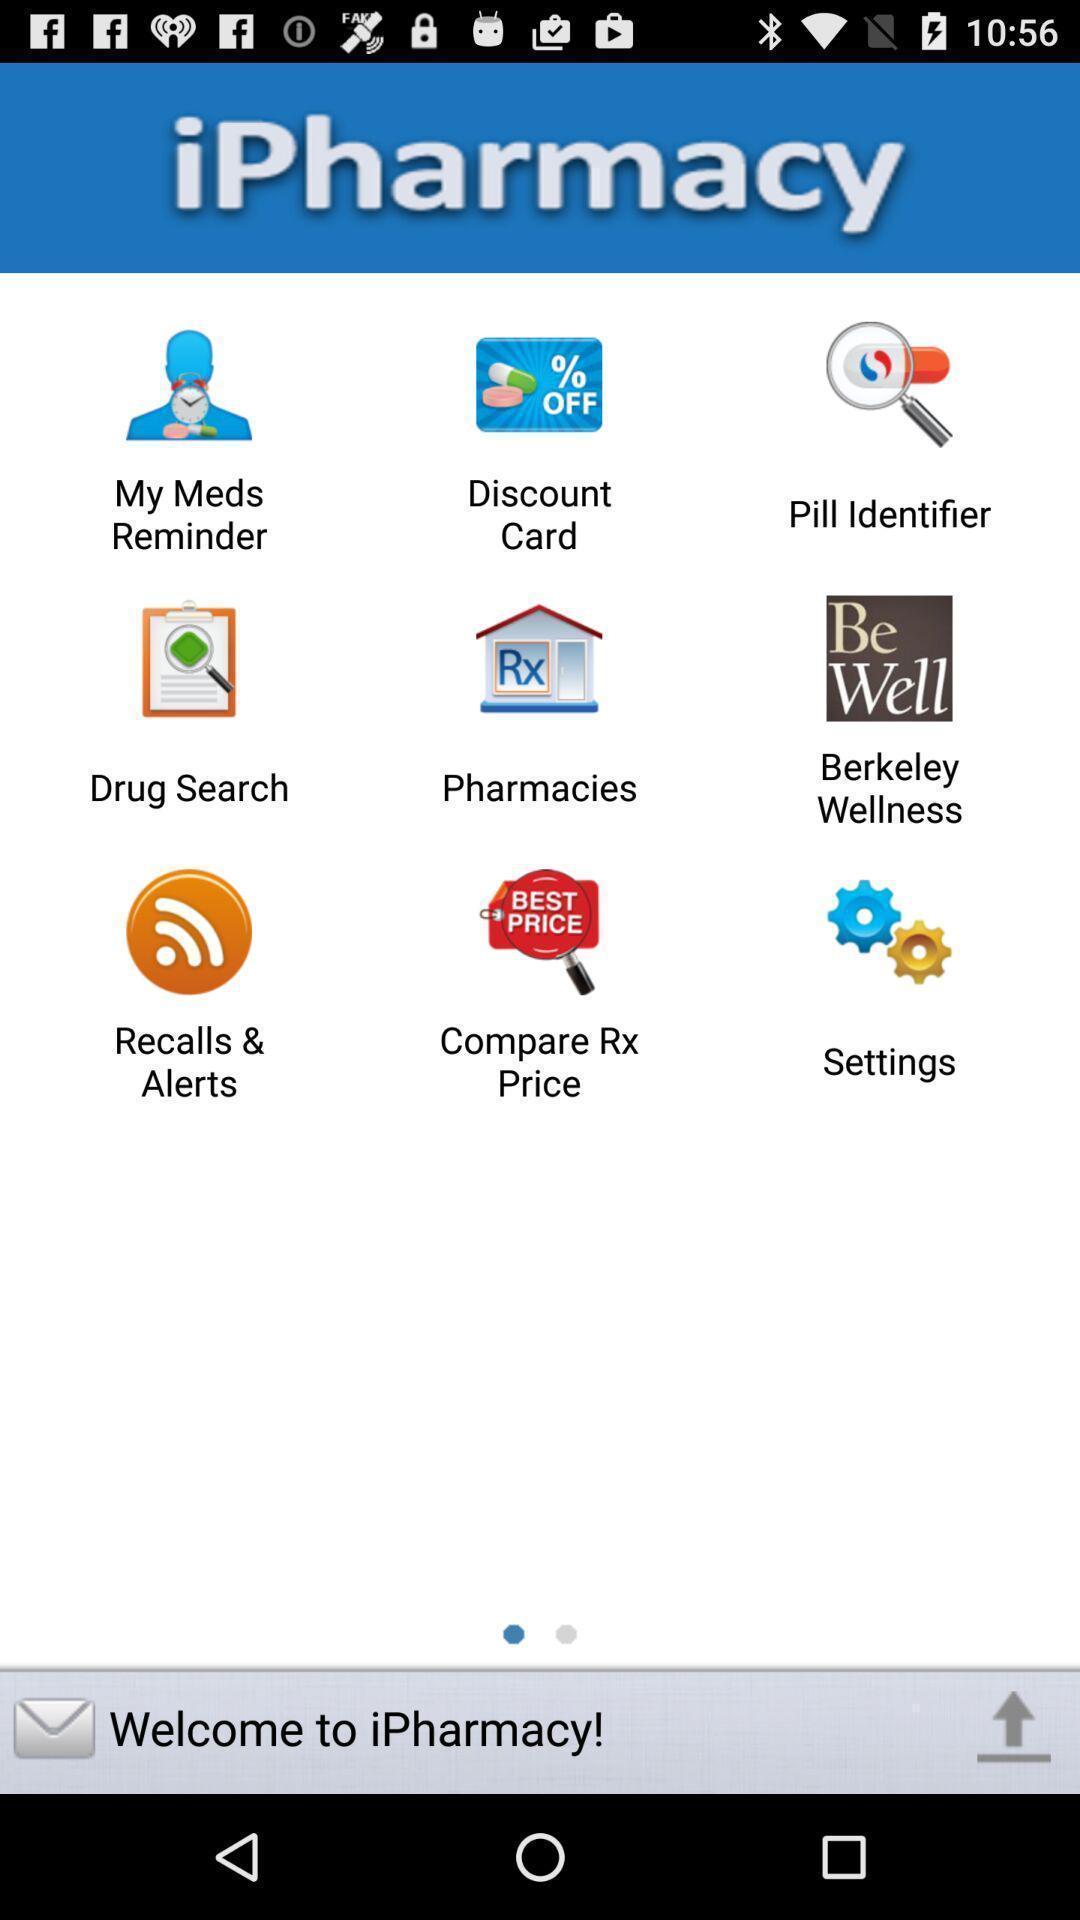What can you discern from this picture? Welcome page of medication app. 